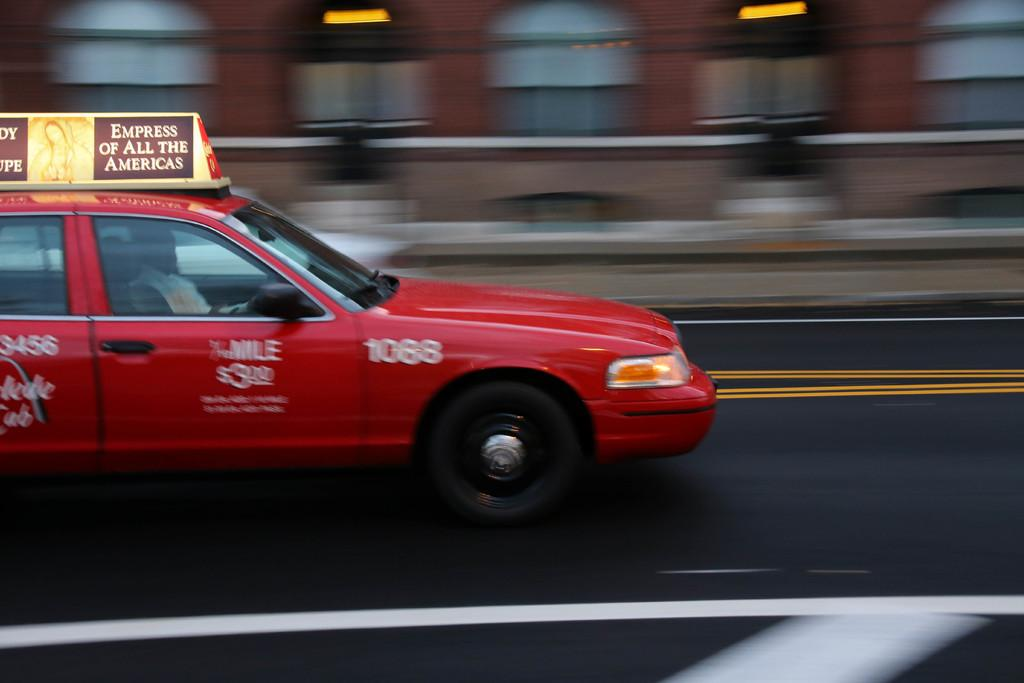<image>
Describe the image concisely. A red taxi is driving down a city street with a sign on top that says Empress of All the Americas. 